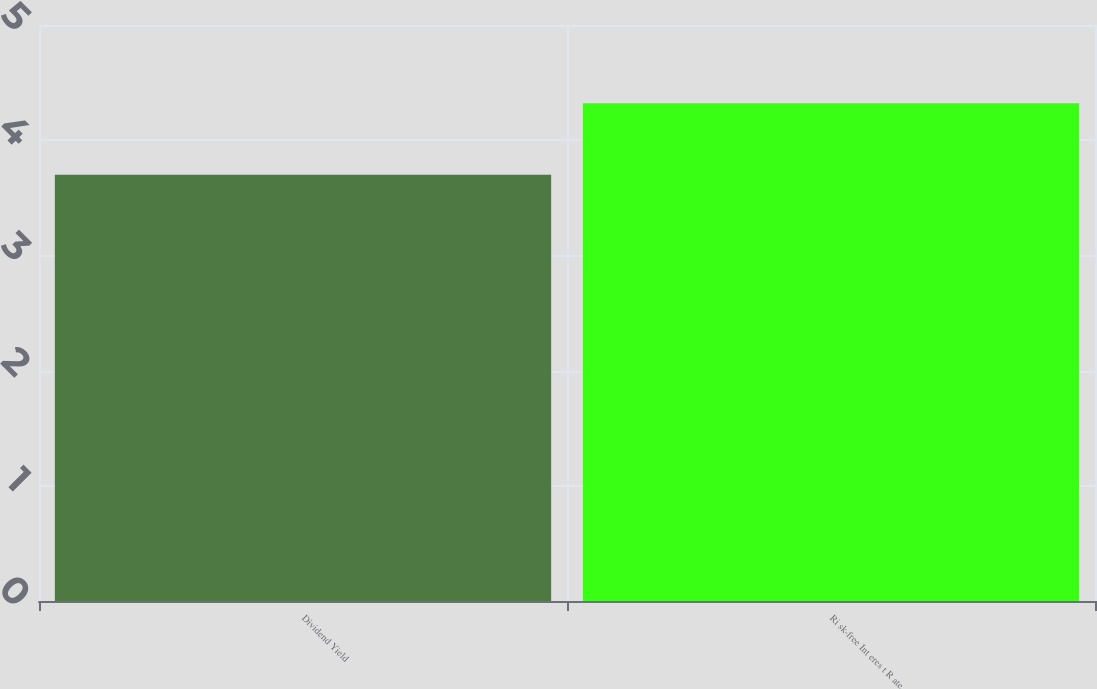Convert chart to OTSL. <chart><loc_0><loc_0><loc_500><loc_500><bar_chart><fcel>Dividend Yield<fcel>Ri sk-free Int eres t R ate<nl><fcel>3.7<fcel>4.32<nl></chart> 